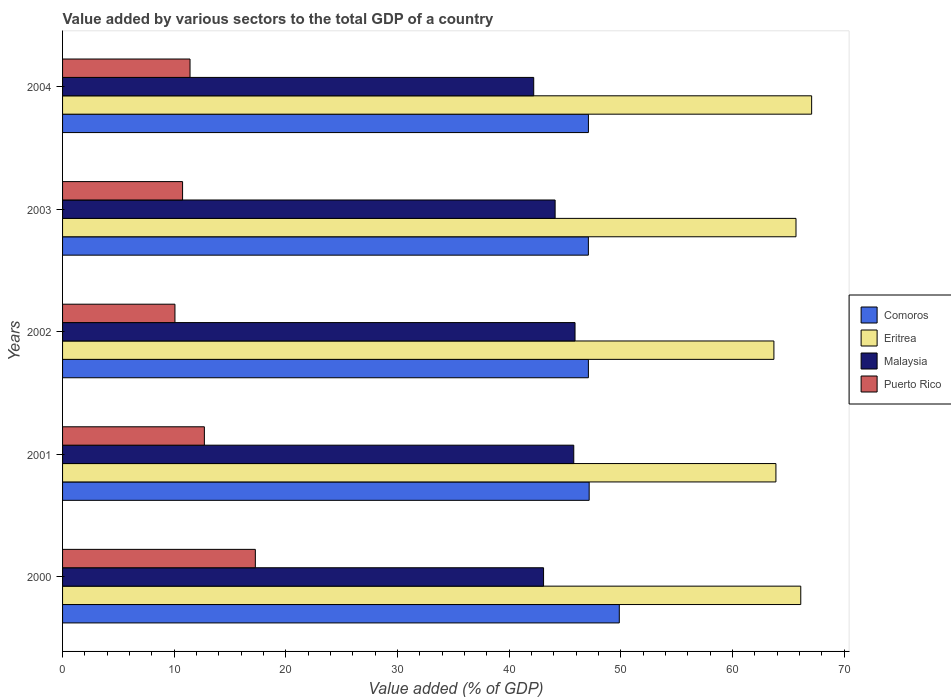How many different coloured bars are there?
Offer a terse response. 4. Are the number of bars per tick equal to the number of legend labels?
Offer a terse response. Yes. How many bars are there on the 2nd tick from the bottom?
Keep it short and to the point. 4. What is the value added by various sectors to the total GDP in Malaysia in 2001?
Your answer should be compact. 45.79. Across all years, what is the maximum value added by various sectors to the total GDP in Eritrea?
Your answer should be very brief. 67.09. Across all years, what is the minimum value added by various sectors to the total GDP in Puerto Rico?
Provide a succinct answer. 10.07. In which year was the value added by various sectors to the total GDP in Puerto Rico maximum?
Your response must be concise. 2000. What is the total value added by various sectors to the total GDP in Eritrea in the graph?
Provide a succinct answer. 326.5. What is the difference between the value added by various sectors to the total GDP in Puerto Rico in 2000 and that in 2004?
Keep it short and to the point. 5.85. What is the difference between the value added by various sectors to the total GDP in Malaysia in 2001 and the value added by various sectors to the total GDP in Puerto Rico in 2003?
Your response must be concise. 35.04. What is the average value added by various sectors to the total GDP in Comoros per year?
Provide a succinct answer. 47.66. In the year 2003, what is the difference between the value added by various sectors to the total GDP in Eritrea and value added by various sectors to the total GDP in Comoros?
Your answer should be very brief. 18.59. What is the ratio of the value added by various sectors to the total GDP in Comoros in 2002 to that in 2004?
Make the answer very short. 1. Is the value added by various sectors to the total GDP in Puerto Rico in 2002 less than that in 2003?
Your response must be concise. Yes. Is the difference between the value added by various sectors to the total GDP in Eritrea in 2000 and 2002 greater than the difference between the value added by various sectors to the total GDP in Comoros in 2000 and 2002?
Your response must be concise. No. What is the difference between the highest and the second highest value added by various sectors to the total GDP in Comoros?
Your answer should be compact. 2.7. What is the difference between the highest and the lowest value added by various sectors to the total GDP in Eritrea?
Your response must be concise. 3.38. In how many years, is the value added by various sectors to the total GDP in Eritrea greater than the average value added by various sectors to the total GDP in Eritrea taken over all years?
Offer a very short reply. 3. What does the 4th bar from the top in 2002 represents?
Keep it short and to the point. Comoros. What does the 4th bar from the bottom in 2002 represents?
Offer a terse response. Puerto Rico. Is it the case that in every year, the sum of the value added by various sectors to the total GDP in Malaysia and value added by various sectors to the total GDP in Comoros is greater than the value added by various sectors to the total GDP in Puerto Rico?
Offer a terse response. Yes. What is the difference between two consecutive major ticks on the X-axis?
Offer a terse response. 10. Are the values on the major ticks of X-axis written in scientific E-notation?
Provide a short and direct response. No. Does the graph contain grids?
Offer a terse response. No. Where does the legend appear in the graph?
Your answer should be compact. Center right. How are the legend labels stacked?
Ensure brevity in your answer.  Vertical. What is the title of the graph?
Your answer should be compact. Value added by various sectors to the total GDP of a country. What is the label or title of the X-axis?
Offer a terse response. Value added (% of GDP). What is the Value added (% of GDP) in Comoros in 2000?
Provide a succinct answer. 49.86. What is the Value added (% of GDP) of Eritrea in 2000?
Offer a terse response. 66.12. What is the Value added (% of GDP) of Malaysia in 2000?
Provide a succinct answer. 43.08. What is the Value added (% of GDP) in Puerto Rico in 2000?
Give a very brief answer. 17.27. What is the Value added (% of GDP) in Comoros in 2001?
Offer a very short reply. 47.17. What is the Value added (% of GDP) of Eritrea in 2001?
Make the answer very short. 63.89. What is the Value added (% of GDP) of Malaysia in 2001?
Keep it short and to the point. 45.79. What is the Value added (% of GDP) of Puerto Rico in 2001?
Ensure brevity in your answer.  12.7. What is the Value added (% of GDP) of Comoros in 2002?
Your response must be concise. 47.09. What is the Value added (% of GDP) in Eritrea in 2002?
Provide a succinct answer. 63.71. What is the Value added (% of GDP) in Malaysia in 2002?
Your response must be concise. 45.9. What is the Value added (% of GDP) in Puerto Rico in 2002?
Your answer should be very brief. 10.07. What is the Value added (% of GDP) in Comoros in 2003?
Offer a very short reply. 47.09. What is the Value added (% of GDP) in Eritrea in 2003?
Provide a succinct answer. 65.69. What is the Value added (% of GDP) in Malaysia in 2003?
Offer a very short reply. 44.12. What is the Value added (% of GDP) of Puerto Rico in 2003?
Provide a succinct answer. 10.75. What is the Value added (% of GDP) in Comoros in 2004?
Offer a very short reply. 47.1. What is the Value added (% of GDP) in Eritrea in 2004?
Your response must be concise. 67.09. What is the Value added (% of GDP) in Malaysia in 2004?
Ensure brevity in your answer.  42.2. What is the Value added (% of GDP) of Puerto Rico in 2004?
Make the answer very short. 11.42. Across all years, what is the maximum Value added (% of GDP) of Comoros?
Offer a very short reply. 49.86. Across all years, what is the maximum Value added (% of GDP) of Eritrea?
Give a very brief answer. 67.09. Across all years, what is the maximum Value added (% of GDP) in Malaysia?
Make the answer very short. 45.9. Across all years, what is the maximum Value added (% of GDP) of Puerto Rico?
Provide a succinct answer. 17.27. Across all years, what is the minimum Value added (% of GDP) in Comoros?
Ensure brevity in your answer.  47.09. Across all years, what is the minimum Value added (% of GDP) of Eritrea?
Make the answer very short. 63.71. Across all years, what is the minimum Value added (% of GDP) of Malaysia?
Offer a terse response. 42.2. Across all years, what is the minimum Value added (% of GDP) of Puerto Rico?
Give a very brief answer. 10.07. What is the total Value added (% of GDP) in Comoros in the graph?
Make the answer very short. 238.32. What is the total Value added (% of GDP) of Eritrea in the graph?
Your answer should be compact. 326.5. What is the total Value added (% of GDP) of Malaysia in the graph?
Make the answer very short. 221.08. What is the total Value added (% of GDP) in Puerto Rico in the graph?
Offer a very short reply. 62.2. What is the difference between the Value added (% of GDP) of Comoros in 2000 and that in 2001?
Keep it short and to the point. 2.7. What is the difference between the Value added (% of GDP) in Eritrea in 2000 and that in 2001?
Provide a succinct answer. 2.23. What is the difference between the Value added (% of GDP) in Malaysia in 2000 and that in 2001?
Your answer should be very brief. -2.7. What is the difference between the Value added (% of GDP) in Puerto Rico in 2000 and that in 2001?
Make the answer very short. 4.57. What is the difference between the Value added (% of GDP) of Comoros in 2000 and that in 2002?
Offer a very short reply. 2.77. What is the difference between the Value added (% of GDP) of Eritrea in 2000 and that in 2002?
Provide a short and direct response. 2.41. What is the difference between the Value added (% of GDP) in Malaysia in 2000 and that in 2002?
Offer a very short reply. -2.82. What is the difference between the Value added (% of GDP) of Puerto Rico in 2000 and that in 2002?
Make the answer very short. 7.2. What is the difference between the Value added (% of GDP) of Comoros in 2000 and that in 2003?
Offer a very short reply. 2.77. What is the difference between the Value added (% of GDP) of Eritrea in 2000 and that in 2003?
Ensure brevity in your answer.  0.43. What is the difference between the Value added (% of GDP) of Malaysia in 2000 and that in 2003?
Your answer should be very brief. -1.03. What is the difference between the Value added (% of GDP) in Puerto Rico in 2000 and that in 2003?
Ensure brevity in your answer.  6.52. What is the difference between the Value added (% of GDP) of Comoros in 2000 and that in 2004?
Make the answer very short. 2.76. What is the difference between the Value added (% of GDP) in Eritrea in 2000 and that in 2004?
Keep it short and to the point. -0.97. What is the difference between the Value added (% of GDP) of Malaysia in 2000 and that in 2004?
Provide a short and direct response. 0.88. What is the difference between the Value added (% of GDP) of Puerto Rico in 2000 and that in 2004?
Give a very brief answer. 5.85. What is the difference between the Value added (% of GDP) in Comoros in 2001 and that in 2002?
Provide a short and direct response. 0.07. What is the difference between the Value added (% of GDP) of Eritrea in 2001 and that in 2002?
Keep it short and to the point. 0.18. What is the difference between the Value added (% of GDP) of Malaysia in 2001 and that in 2002?
Provide a succinct answer. -0.11. What is the difference between the Value added (% of GDP) of Puerto Rico in 2001 and that in 2002?
Provide a short and direct response. 2.64. What is the difference between the Value added (% of GDP) in Comoros in 2001 and that in 2003?
Your answer should be compact. 0.07. What is the difference between the Value added (% of GDP) of Eritrea in 2001 and that in 2003?
Ensure brevity in your answer.  -1.8. What is the difference between the Value added (% of GDP) in Malaysia in 2001 and that in 2003?
Offer a very short reply. 1.67. What is the difference between the Value added (% of GDP) of Puerto Rico in 2001 and that in 2003?
Make the answer very short. 1.95. What is the difference between the Value added (% of GDP) in Comoros in 2001 and that in 2004?
Offer a very short reply. 0.07. What is the difference between the Value added (% of GDP) in Eritrea in 2001 and that in 2004?
Keep it short and to the point. -3.2. What is the difference between the Value added (% of GDP) of Malaysia in 2001 and that in 2004?
Offer a very short reply. 3.59. What is the difference between the Value added (% of GDP) of Puerto Rico in 2001 and that in 2004?
Your response must be concise. 1.29. What is the difference between the Value added (% of GDP) in Eritrea in 2002 and that in 2003?
Give a very brief answer. -1.98. What is the difference between the Value added (% of GDP) of Malaysia in 2002 and that in 2003?
Keep it short and to the point. 1.78. What is the difference between the Value added (% of GDP) of Puerto Rico in 2002 and that in 2003?
Provide a succinct answer. -0.68. What is the difference between the Value added (% of GDP) in Comoros in 2002 and that in 2004?
Give a very brief answer. -0. What is the difference between the Value added (% of GDP) in Eritrea in 2002 and that in 2004?
Keep it short and to the point. -3.38. What is the difference between the Value added (% of GDP) of Malaysia in 2002 and that in 2004?
Give a very brief answer. 3.7. What is the difference between the Value added (% of GDP) of Puerto Rico in 2002 and that in 2004?
Your response must be concise. -1.35. What is the difference between the Value added (% of GDP) in Comoros in 2003 and that in 2004?
Ensure brevity in your answer.  -0. What is the difference between the Value added (% of GDP) in Eritrea in 2003 and that in 2004?
Provide a succinct answer. -1.4. What is the difference between the Value added (% of GDP) in Malaysia in 2003 and that in 2004?
Your answer should be compact. 1.92. What is the difference between the Value added (% of GDP) in Puerto Rico in 2003 and that in 2004?
Offer a very short reply. -0.67. What is the difference between the Value added (% of GDP) of Comoros in 2000 and the Value added (% of GDP) of Eritrea in 2001?
Keep it short and to the point. -14.03. What is the difference between the Value added (% of GDP) in Comoros in 2000 and the Value added (% of GDP) in Malaysia in 2001?
Provide a succinct answer. 4.08. What is the difference between the Value added (% of GDP) in Comoros in 2000 and the Value added (% of GDP) in Puerto Rico in 2001?
Give a very brief answer. 37.16. What is the difference between the Value added (% of GDP) in Eritrea in 2000 and the Value added (% of GDP) in Malaysia in 2001?
Your answer should be very brief. 20.33. What is the difference between the Value added (% of GDP) of Eritrea in 2000 and the Value added (% of GDP) of Puerto Rico in 2001?
Offer a very short reply. 53.42. What is the difference between the Value added (% of GDP) in Malaysia in 2000 and the Value added (% of GDP) in Puerto Rico in 2001?
Keep it short and to the point. 30.38. What is the difference between the Value added (% of GDP) of Comoros in 2000 and the Value added (% of GDP) of Eritrea in 2002?
Offer a very short reply. -13.85. What is the difference between the Value added (% of GDP) in Comoros in 2000 and the Value added (% of GDP) in Malaysia in 2002?
Keep it short and to the point. 3.96. What is the difference between the Value added (% of GDP) in Comoros in 2000 and the Value added (% of GDP) in Puerto Rico in 2002?
Make the answer very short. 39.8. What is the difference between the Value added (% of GDP) in Eritrea in 2000 and the Value added (% of GDP) in Malaysia in 2002?
Provide a short and direct response. 20.22. What is the difference between the Value added (% of GDP) in Eritrea in 2000 and the Value added (% of GDP) in Puerto Rico in 2002?
Keep it short and to the point. 56.05. What is the difference between the Value added (% of GDP) of Malaysia in 2000 and the Value added (% of GDP) of Puerto Rico in 2002?
Provide a succinct answer. 33.01. What is the difference between the Value added (% of GDP) in Comoros in 2000 and the Value added (% of GDP) in Eritrea in 2003?
Ensure brevity in your answer.  -15.83. What is the difference between the Value added (% of GDP) in Comoros in 2000 and the Value added (% of GDP) in Malaysia in 2003?
Your answer should be very brief. 5.75. What is the difference between the Value added (% of GDP) in Comoros in 2000 and the Value added (% of GDP) in Puerto Rico in 2003?
Provide a succinct answer. 39.12. What is the difference between the Value added (% of GDP) of Eritrea in 2000 and the Value added (% of GDP) of Malaysia in 2003?
Provide a short and direct response. 22. What is the difference between the Value added (% of GDP) of Eritrea in 2000 and the Value added (% of GDP) of Puerto Rico in 2003?
Offer a terse response. 55.37. What is the difference between the Value added (% of GDP) in Malaysia in 2000 and the Value added (% of GDP) in Puerto Rico in 2003?
Ensure brevity in your answer.  32.33. What is the difference between the Value added (% of GDP) of Comoros in 2000 and the Value added (% of GDP) of Eritrea in 2004?
Offer a terse response. -17.23. What is the difference between the Value added (% of GDP) in Comoros in 2000 and the Value added (% of GDP) in Malaysia in 2004?
Your answer should be compact. 7.66. What is the difference between the Value added (% of GDP) in Comoros in 2000 and the Value added (% of GDP) in Puerto Rico in 2004?
Make the answer very short. 38.45. What is the difference between the Value added (% of GDP) in Eritrea in 2000 and the Value added (% of GDP) in Malaysia in 2004?
Make the answer very short. 23.92. What is the difference between the Value added (% of GDP) of Eritrea in 2000 and the Value added (% of GDP) of Puerto Rico in 2004?
Keep it short and to the point. 54.7. What is the difference between the Value added (% of GDP) in Malaysia in 2000 and the Value added (% of GDP) in Puerto Rico in 2004?
Offer a very short reply. 31.66. What is the difference between the Value added (% of GDP) of Comoros in 2001 and the Value added (% of GDP) of Eritrea in 2002?
Offer a very short reply. -16.55. What is the difference between the Value added (% of GDP) of Comoros in 2001 and the Value added (% of GDP) of Malaysia in 2002?
Ensure brevity in your answer.  1.27. What is the difference between the Value added (% of GDP) of Comoros in 2001 and the Value added (% of GDP) of Puerto Rico in 2002?
Your response must be concise. 37.1. What is the difference between the Value added (% of GDP) of Eritrea in 2001 and the Value added (% of GDP) of Malaysia in 2002?
Ensure brevity in your answer.  17.99. What is the difference between the Value added (% of GDP) in Eritrea in 2001 and the Value added (% of GDP) in Puerto Rico in 2002?
Give a very brief answer. 53.83. What is the difference between the Value added (% of GDP) of Malaysia in 2001 and the Value added (% of GDP) of Puerto Rico in 2002?
Provide a succinct answer. 35.72. What is the difference between the Value added (% of GDP) in Comoros in 2001 and the Value added (% of GDP) in Eritrea in 2003?
Offer a very short reply. -18.52. What is the difference between the Value added (% of GDP) of Comoros in 2001 and the Value added (% of GDP) of Malaysia in 2003?
Provide a succinct answer. 3.05. What is the difference between the Value added (% of GDP) in Comoros in 2001 and the Value added (% of GDP) in Puerto Rico in 2003?
Keep it short and to the point. 36.42. What is the difference between the Value added (% of GDP) in Eritrea in 2001 and the Value added (% of GDP) in Malaysia in 2003?
Your answer should be compact. 19.78. What is the difference between the Value added (% of GDP) of Eritrea in 2001 and the Value added (% of GDP) of Puerto Rico in 2003?
Offer a terse response. 53.14. What is the difference between the Value added (% of GDP) in Malaysia in 2001 and the Value added (% of GDP) in Puerto Rico in 2003?
Ensure brevity in your answer.  35.04. What is the difference between the Value added (% of GDP) in Comoros in 2001 and the Value added (% of GDP) in Eritrea in 2004?
Offer a very short reply. -19.93. What is the difference between the Value added (% of GDP) in Comoros in 2001 and the Value added (% of GDP) in Malaysia in 2004?
Your answer should be compact. 4.97. What is the difference between the Value added (% of GDP) in Comoros in 2001 and the Value added (% of GDP) in Puerto Rico in 2004?
Your answer should be compact. 35.75. What is the difference between the Value added (% of GDP) of Eritrea in 2001 and the Value added (% of GDP) of Malaysia in 2004?
Your answer should be compact. 21.69. What is the difference between the Value added (% of GDP) of Eritrea in 2001 and the Value added (% of GDP) of Puerto Rico in 2004?
Keep it short and to the point. 52.48. What is the difference between the Value added (% of GDP) of Malaysia in 2001 and the Value added (% of GDP) of Puerto Rico in 2004?
Your answer should be very brief. 34.37. What is the difference between the Value added (% of GDP) in Comoros in 2002 and the Value added (% of GDP) in Eritrea in 2003?
Your answer should be compact. -18.59. What is the difference between the Value added (% of GDP) of Comoros in 2002 and the Value added (% of GDP) of Malaysia in 2003?
Your answer should be compact. 2.98. What is the difference between the Value added (% of GDP) of Comoros in 2002 and the Value added (% of GDP) of Puerto Rico in 2003?
Offer a terse response. 36.35. What is the difference between the Value added (% of GDP) in Eritrea in 2002 and the Value added (% of GDP) in Malaysia in 2003?
Keep it short and to the point. 19.6. What is the difference between the Value added (% of GDP) in Eritrea in 2002 and the Value added (% of GDP) in Puerto Rico in 2003?
Your answer should be compact. 52.96. What is the difference between the Value added (% of GDP) of Malaysia in 2002 and the Value added (% of GDP) of Puerto Rico in 2003?
Make the answer very short. 35.15. What is the difference between the Value added (% of GDP) of Comoros in 2002 and the Value added (% of GDP) of Eritrea in 2004?
Provide a short and direct response. -20. What is the difference between the Value added (% of GDP) of Comoros in 2002 and the Value added (% of GDP) of Malaysia in 2004?
Offer a very short reply. 4.9. What is the difference between the Value added (% of GDP) in Comoros in 2002 and the Value added (% of GDP) in Puerto Rico in 2004?
Your answer should be very brief. 35.68. What is the difference between the Value added (% of GDP) in Eritrea in 2002 and the Value added (% of GDP) in Malaysia in 2004?
Offer a terse response. 21.51. What is the difference between the Value added (% of GDP) in Eritrea in 2002 and the Value added (% of GDP) in Puerto Rico in 2004?
Keep it short and to the point. 52.3. What is the difference between the Value added (% of GDP) in Malaysia in 2002 and the Value added (% of GDP) in Puerto Rico in 2004?
Provide a succinct answer. 34.48. What is the difference between the Value added (% of GDP) in Comoros in 2003 and the Value added (% of GDP) in Eritrea in 2004?
Offer a terse response. -20. What is the difference between the Value added (% of GDP) of Comoros in 2003 and the Value added (% of GDP) of Malaysia in 2004?
Ensure brevity in your answer.  4.9. What is the difference between the Value added (% of GDP) of Comoros in 2003 and the Value added (% of GDP) of Puerto Rico in 2004?
Your response must be concise. 35.68. What is the difference between the Value added (% of GDP) in Eritrea in 2003 and the Value added (% of GDP) in Malaysia in 2004?
Make the answer very short. 23.49. What is the difference between the Value added (% of GDP) of Eritrea in 2003 and the Value added (% of GDP) of Puerto Rico in 2004?
Keep it short and to the point. 54.27. What is the difference between the Value added (% of GDP) of Malaysia in 2003 and the Value added (% of GDP) of Puerto Rico in 2004?
Offer a very short reply. 32.7. What is the average Value added (% of GDP) of Comoros per year?
Offer a very short reply. 47.66. What is the average Value added (% of GDP) in Eritrea per year?
Offer a very short reply. 65.3. What is the average Value added (% of GDP) in Malaysia per year?
Your answer should be very brief. 44.22. What is the average Value added (% of GDP) of Puerto Rico per year?
Make the answer very short. 12.44. In the year 2000, what is the difference between the Value added (% of GDP) of Comoros and Value added (% of GDP) of Eritrea?
Keep it short and to the point. -16.25. In the year 2000, what is the difference between the Value added (% of GDP) in Comoros and Value added (% of GDP) in Malaysia?
Keep it short and to the point. 6.78. In the year 2000, what is the difference between the Value added (% of GDP) in Comoros and Value added (% of GDP) in Puerto Rico?
Provide a short and direct response. 32.6. In the year 2000, what is the difference between the Value added (% of GDP) in Eritrea and Value added (% of GDP) in Malaysia?
Ensure brevity in your answer.  23.04. In the year 2000, what is the difference between the Value added (% of GDP) of Eritrea and Value added (% of GDP) of Puerto Rico?
Provide a short and direct response. 48.85. In the year 2000, what is the difference between the Value added (% of GDP) in Malaysia and Value added (% of GDP) in Puerto Rico?
Ensure brevity in your answer.  25.81. In the year 2001, what is the difference between the Value added (% of GDP) in Comoros and Value added (% of GDP) in Eritrea?
Ensure brevity in your answer.  -16.73. In the year 2001, what is the difference between the Value added (% of GDP) of Comoros and Value added (% of GDP) of Malaysia?
Your answer should be very brief. 1.38. In the year 2001, what is the difference between the Value added (% of GDP) in Comoros and Value added (% of GDP) in Puerto Rico?
Offer a terse response. 34.46. In the year 2001, what is the difference between the Value added (% of GDP) in Eritrea and Value added (% of GDP) in Malaysia?
Offer a very short reply. 18.11. In the year 2001, what is the difference between the Value added (% of GDP) of Eritrea and Value added (% of GDP) of Puerto Rico?
Your answer should be compact. 51.19. In the year 2001, what is the difference between the Value added (% of GDP) in Malaysia and Value added (% of GDP) in Puerto Rico?
Your answer should be very brief. 33.08. In the year 2002, what is the difference between the Value added (% of GDP) in Comoros and Value added (% of GDP) in Eritrea?
Keep it short and to the point. -16.62. In the year 2002, what is the difference between the Value added (% of GDP) of Comoros and Value added (% of GDP) of Malaysia?
Give a very brief answer. 1.2. In the year 2002, what is the difference between the Value added (% of GDP) in Comoros and Value added (% of GDP) in Puerto Rico?
Keep it short and to the point. 37.03. In the year 2002, what is the difference between the Value added (% of GDP) of Eritrea and Value added (% of GDP) of Malaysia?
Make the answer very short. 17.81. In the year 2002, what is the difference between the Value added (% of GDP) of Eritrea and Value added (% of GDP) of Puerto Rico?
Ensure brevity in your answer.  53.65. In the year 2002, what is the difference between the Value added (% of GDP) of Malaysia and Value added (% of GDP) of Puerto Rico?
Your response must be concise. 35.83. In the year 2003, what is the difference between the Value added (% of GDP) of Comoros and Value added (% of GDP) of Eritrea?
Offer a very short reply. -18.59. In the year 2003, what is the difference between the Value added (% of GDP) in Comoros and Value added (% of GDP) in Malaysia?
Offer a terse response. 2.98. In the year 2003, what is the difference between the Value added (% of GDP) of Comoros and Value added (% of GDP) of Puerto Rico?
Make the answer very short. 36.35. In the year 2003, what is the difference between the Value added (% of GDP) of Eritrea and Value added (% of GDP) of Malaysia?
Your answer should be compact. 21.57. In the year 2003, what is the difference between the Value added (% of GDP) in Eritrea and Value added (% of GDP) in Puerto Rico?
Your answer should be very brief. 54.94. In the year 2003, what is the difference between the Value added (% of GDP) in Malaysia and Value added (% of GDP) in Puerto Rico?
Your answer should be very brief. 33.37. In the year 2004, what is the difference between the Value added (% of GDP) of Comoros and Value added (% of GDP) of Eritrea?
Your answer should be compact. -19.99. In the year 2004, what is the difference between the Value added (% of GDP) of Comoros and Value added (% of GDP) of Malaysia?
Offer a very short reply. 4.9. In the year 2004, what is the difference between the Value added (% of GDP) in Comoros and Value added (% of GDP) in Puerto Rico?
Your response must be concise. 35.68. In the year 2004, what is the difference between the Value added (% of GDP) of Eritrea and Value added (% of GDP) of Malaysia?
Give a very brief answer. 24.89. In the year 2004, what is the difference between the Value added (% of GDP) of Eritrea and Value added (% of GDP) of Puerto Rico?
Your answer should be very brief. 55.68. In the year 2004, what is the difference between the Value added (% of GDP) of Malaysia and Value added (% of GDP) of Puerto Rico?
Provide a short and direct response. 30.78. What is the ratio of the Value added (% of GDP) in Comoros in 2000 to that in 2001?
Offer a terse response. 1.06. What is the ratio of the Value added (% of GDP) in Eritrea in 2000 to that in 2001?
Ensure brevity in your answer.  1.03. What is the ratio of the Value added (% of GDP) of Malaysia in 2000 to that in 2001?
Give a very brief answer. 0.94. What is the ratio of the Value added (% of GDP) of Puerto Rico in 2000 to that in 2001?
Make the answer very short. 1.36. What is the ratio of the Value added (% of GDP) in Comoros in 2000 to that in 2002?
Offer a terse response. 1.06. What is the ratio of the Value added (% of GDP) of Eritrea in 2000 to that in 2002?
Ensure brevity in your answer.  1.04. What is the ratio of the Value added (% of GDP) of Malaysia in 2000 to that in 2002?
Keep it short and to the point. 0.94. What is the ratio of the Value added (% of GDP) of Puerto Rico in 2000 to that in 2002?
Your answer should be very brief. 1.72. What is the ratio of the Value added (% of GDP) in Comoros in 2000 to that in 2003?
Ensure brevity in your answer.  1.06. What is the ratio of the Value added (% of GDP) in Malaysia in 2000 to that in 2003?
Make the answer very short. 0.98. What is the ratio of the Value added (% of GDP) of Puerto Rico in 2000 to that in 2003?
Make the answer very short. 1.61. What is the ratio of the Value added (% of GDP) in Comoros in 2000 to that in 2004?
Offer a very short reply. 1.06. What is the ratio of the Value added (% of GDP) in Eritrea in 2000 to that in 2004?
Your answer should be compact. 0.99. What is the ratio of the Value added (% of GDP) in Malaysia in 2000 to that in 2004?
Your response must be concise. 1.02. What is the ratio of the Value added (% of GDP) in Puerto Rico in 2000 to that in 2004?
Give a very brief answer. 1.51. What is the ratio of the Value added (% of GDP) in Eritrea in 2001 to that in 2002?
Provide a short and direct response. 1. What is the ratio of the Value added (% of GDP) in Malaysia in 2001 to that in 2002?
Provide a short and direct response. 1. What is the ratio of the Value added (% of GDP) of Puerto Rico in 2001 to that in 2002?
Give a very brief answer. 1.26. What is the ratio of the Value added (% of GDP) of Comoros in 2001 to that in 2003?
Provide a succinct answer. 1. What is the ratio of the Value added (% of GDP) in Eritrea in 2001 to that in 2003?
Provide a succinct answer. 0.97. What is the ratio of the Value added (% of GDP) of Malaysia in 2001 to that in 2003?
Your answer should be very brief. 1.04. What is the ratio of the Value added (% of GDP) of Puerto Rico in 2001 to that in 2003?
Your answer should be very brief. 1.18. What is the ratio of the Value added (% of GDP) in Comoros in 2001 to that in 2004?
Offer a terse response. 1. What is the ratio of the Value added (% of GDP) in Eritrea in 2001 to that in 2004?
Make the answer very short. 0.95. What is the ratio of the Value added (% of GDP) of Malaysia in 2001 to that in 2004?
Provide a short and direct response. 1.08. What is the ratio of the Value added (% of GDP) of Puerto Rico in 2001 to that in 2004?
Ensure brevity in your answer.  1.11. What is the ratio of the Value added (% of GDP) in Eritrea in 2002 to that in 2003?
Your response must be concise. 0.97. What is the ratio of the Value added (% of GDP) of Malaysia in 2002 to that in 2003?
Your answer should be very brief. 1.04. What is the ratio of the Value added (% of GDP) of Puerto Rico in 2002 to that in 2003?
Your answer should be very brief. 0.94. What is the ratio of the Value added (% of GDP) of Comoros in 2002 to that in 2004?
Provide a short and direct response. 1. What is the ratio of the Value added (% of GDP) in Eritrea in 2002 to that in 2004?
Offer a terse response. 0.95. What is the ratio of the Value added (% of GDP) in Malaysia in 2002 to that in 2004?
Keep it short and to the point. 1.09. What is the ratio of the Value added (% of GDP) in Puerto Rico in 2002 to that in 2004?
Give a very brief answer. 0.88. What is the ratio of the Value added (% of GDP) of Comoros in 2003 to that in 2004?
Keep it short and to the point. 1. What is the ratio of the Value added (% of GDP) of Eritrea in 2003 to that in 2004?
Keep it short and to the point. 0.98. What is the ratio of the Value added (% of GDP) of Malaysia in 2003 to that in 2004?
Provide a succinct answer. 1.05. What is the ratio of the Value added (% of GDP) in Puerto Rico in 2003 to that in 2004?
Make the answer very short. 0.94. What is the difference between the highest and the second highest Value added (% of GDP) of Comoros?
Offer a terse response. 2.7. What is the difference between the highest and the second highest Value added (% of GDP) in Malaysia?
Offer a very short reply. 0.11. What is the difference between the highest and the second highest Value added (% of GDP) in Puerto Rico?
Your answer should be compact. 4.57. What is the difference between the highest and the lowest Value added (% of GDP) of Comoros?
Offer a very short reply. 2.77. What is the difference between the highest and the lowest Value added (% of GDP) of Eritrea?
Keep it short and to the point. 3.38. What is the difference between the highest and the lowest Value added (% of GDP) in Malaysia?
Your response must be concise. 3.7. What is the difference between the highest and the lowest Value added (% of GDP) in Puerto Rico?
Your response must be concise. 7.2. 